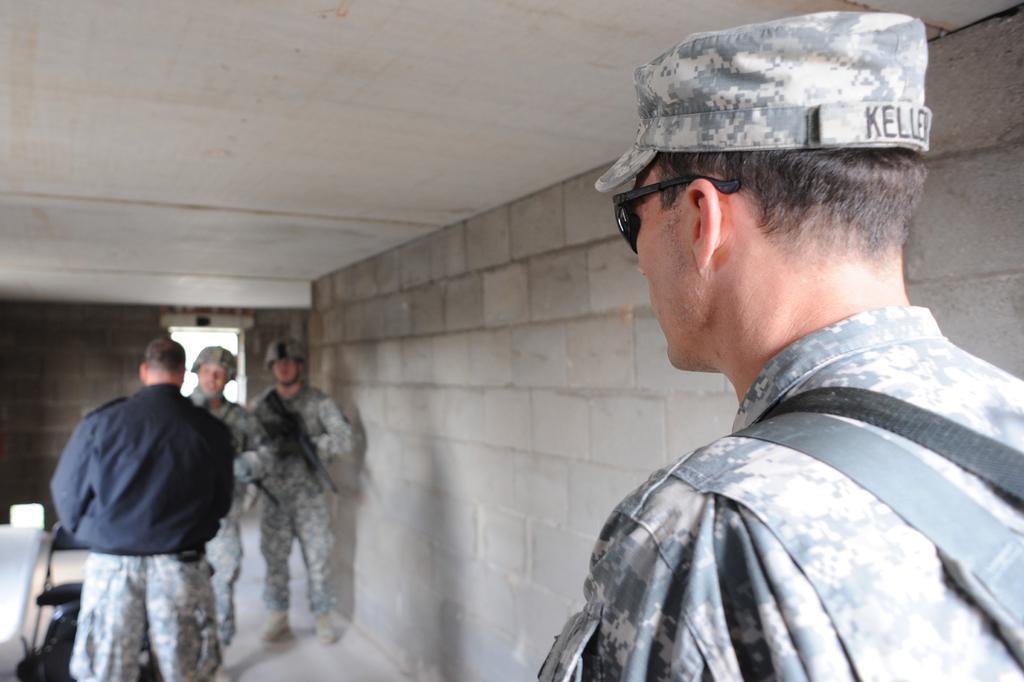Can you describe this image briefly? In this image we can see a few people in a room and they are wearing army uniform and there are two people holding guns in their hands and we can see some objects on the floor. 